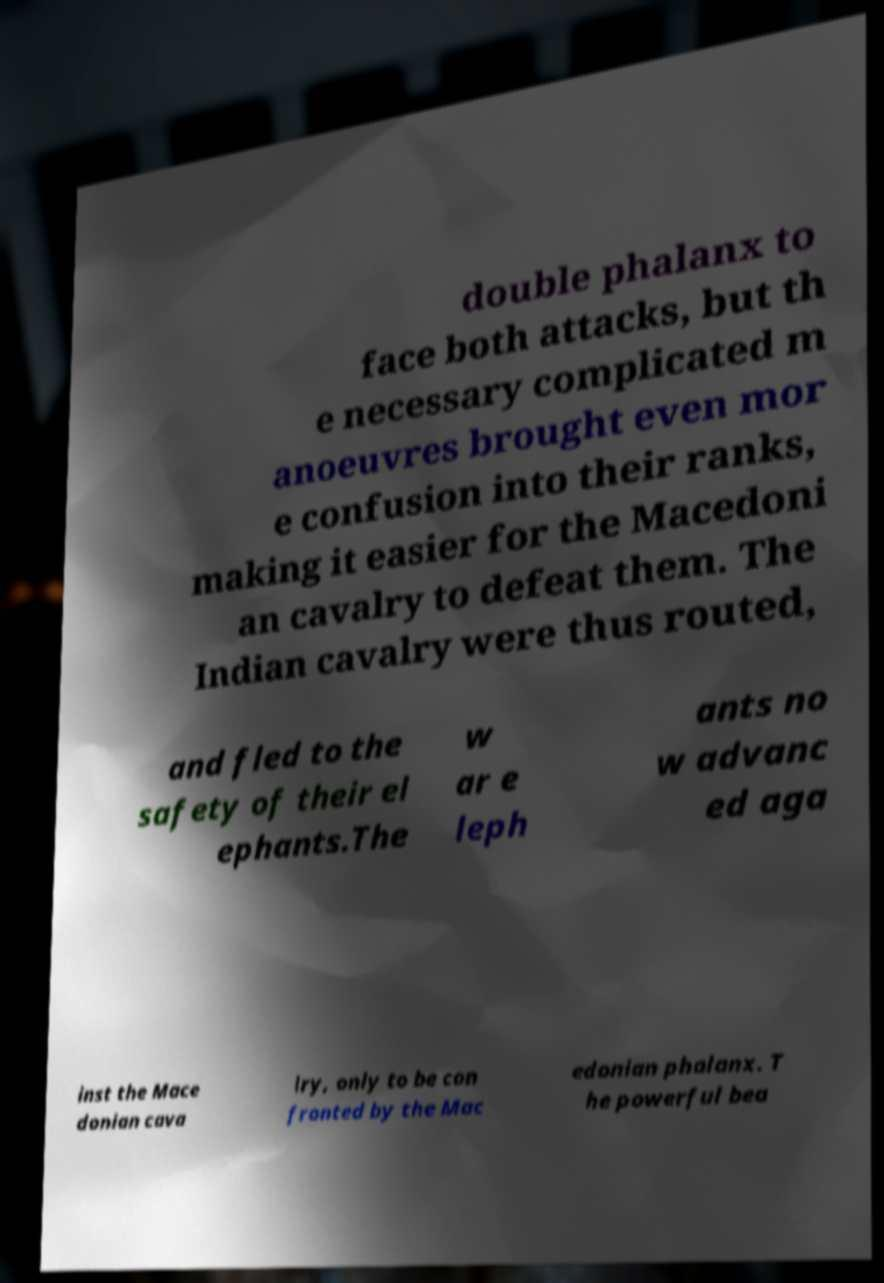Could you assist in decoding the text presented in this image and type it out clearly? double phalanx to face both attacks, but th e necessary complicated m anoeuvres brought even mor e confusion into their ranks, making it easier for the Macedoni an cavalry to defeat them. The Indian cavalry were thus routed, and fled to the safety of their el ephants.The w ar e leph ants no w advanc ed aga inst the Mace donian cava lry, only to be con fronted by the Mac edonian phalanx. T he powerful bea 